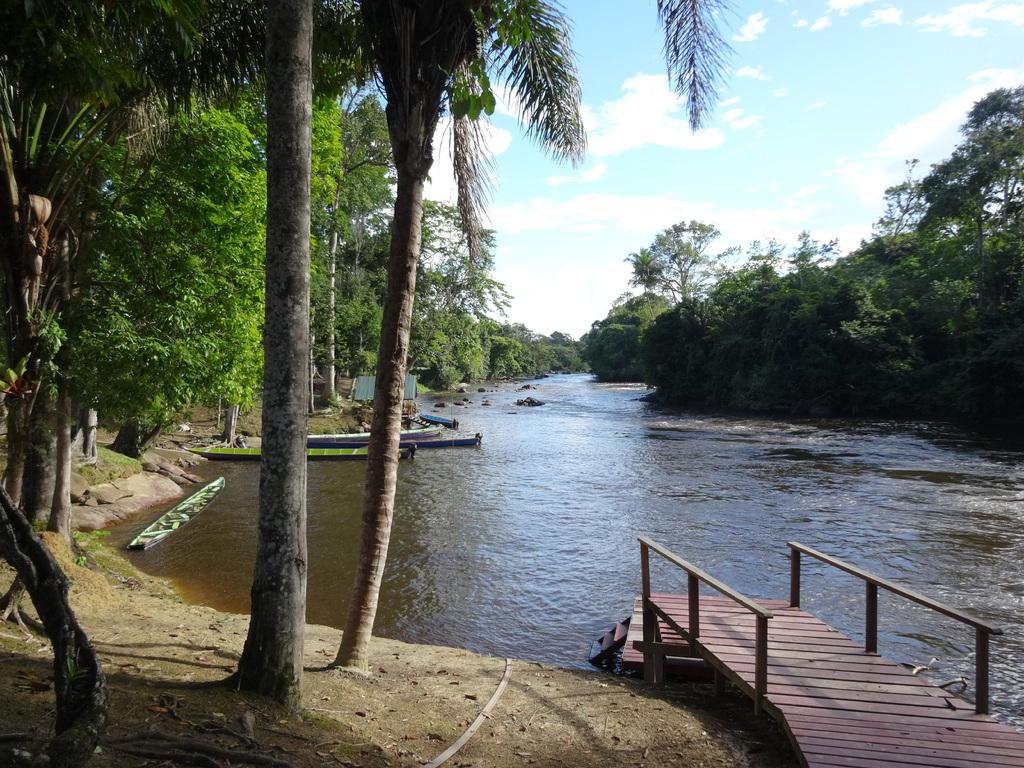How would you summarize this image in a sentence or two? In this image we can see the bridge, land, dried leaves, trees and also the boats on the surface of the river. We can also see the sky with the clouds. 